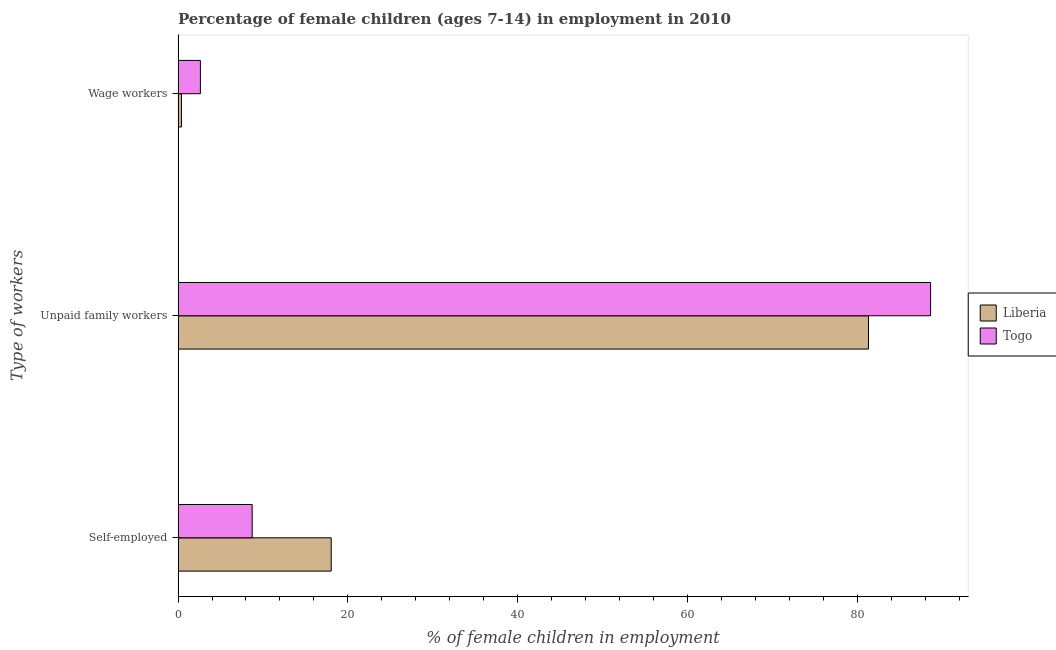How many groups of bars are there?
Ensure brevity in your answer.  3. Are the number of bars on each tick of the Y-axis equal?
Your response must be concise. Yes. How many bars are there on the 1st tick from the top?
Provide a succinct answer. 2. How many bars are there on the 2nd tick from the bottom?
Keep it short and to the point. 2. What is the label of the 1st group of bars from the top?
Give a very brief answer. Wage workers. What is the percentage of children employed as wage workers in Liberia?
Provide a short and direct response. 0.4. Across all countries, what is the maximum percentage of self employed children?
Your answer should be very brief. 18.04. Across all countries, what is the minimum percentage of self employed children?
Offer a terse response. 8.73. In which country was the percentage of children employed as unpaid family workers maximum?
Your response must be concise. Togo. In which country was the percentage of children employed as unpaid family workers minimum?
Your response must be concise. Liberia. What is the total percentage of children employed as wage workers in the graph?
Keep it short and to the point. 3.03. What is the difference between the percentage of self employed children in Togo and that in Liberia?
Your answer should be very brief. -9.31. What is the difference between the percentage of children employed as wage workers in Liberia and the percentage of children employed as unpaid family workers in Togo?
Make the answer very short. -88.24. What is the average percentage of self employed children per country?
Give a very brief answer. 13.38. What is the difference between the percentage of children employed as unpaid family workers and percentage of children employed as wage workers in Togo?
Your response must be concise. 86.01. What is the ratio of the percentage of children employed as wage workers in Liberia to that in Togo?
Ensure brevity in your answer.  0.15. Is the difference between the percentage of self employed children in Togo and Liberia greater than the difference between the percentage of children employed as unpaid family workers in Togo and Liberia?
Provide a short and direct response. No. What is the difference between the highest and the second highest percentage of self employed children?
Your response must be concise. 9.31. What is the difference between the highest and the lowest percentage of children employed as wage workers?
Provide a short and direct response. 2.23. In how many countries, is the percentage of children employed as wage workers greater than the average percentage of children employed as wage workers taken over all countries?
Provide a short and direct response. 1. Is the sum of the percentage of children employed as unpaid family workers in Togo and Liberia greater than the maximum percentage of self employed children across all countries?
Your answer should be compact. Yes. What does the 1st bar from the top in Wage workers represents?
Your response must be concise. Togo. What does the 2nd bar from the bottom in Self-employed represents?
Make the answer very short. Togo. Is it the case that in every country, the sum of the percentage of self employed children and percentage of children employed as unpaid family workers is greater than the percentage of children employed as wage workers?
Ensure brevity in your answer.  Yes. How many bars are there?
Your answer should be very brief. 6. How many countries are there in the graph?
Keep it short and to the point. 2. Are the values on the major ticks of X-axis written in scientific E-notation?
Your answer should be very brief. No. Does the graph contain any zero values?
Provide a succinct answer. No. Where does the legend appear in the graph?
Provide a succinct answer. Center right. How are the legend labels stacked?
Ensure brevity in your answer.  Vertical. What is the title of the graph?
Your answer should be compact. Percentage of female children (ages 7-14) in employment in 2010. What is the label or title of the X-axis?
Offer a very short reply. % of female children in employment. What is the label or title of the Y-axis?
Make the answer very short. Type of workers. What is the % of female children in employment of Liberia in Self-employed?
Provide a succinct answer. 18.04. What is the % of female children in employment of Togo in Self-employed?
Provide a short and direct response. 8.73. What is the % of female children in employment in Liberia in Unpaid family workers?
Ensure brevity in your answer.  81.32. What is the % of female children in employment in Togo in Unpaid family workers?
Ensure brevity in your answer.  88.64. What is the % of female children in employment in Togo in Wage workers?
Ensure brevity in your answer.  2.63. Across all Type of workers, what is the maximum % of female children in employment of Liberia?
Give a very brief answer. 81.32. Across all Type of workers, what is the maximum % of female children in employment in Togo?
Offer a terse response. 88.64. Across all Type of workers, what is the minimum % of female children in employment in Togo?
Offer a terse response. 2.63. What is the total % of female children in employment in Liberia in the graph?
Offer a very short reply. 99.76. What is the difference between the % of female children in employment of Liberia in Self-employed and that in Unpaid family workers?
Keep it short and to the point. -63.28. What is the difference between the % of female children in employment of Togo in Self-employed and that in Unpaid family workers?
Keep it short and to the point. -79.91. What is the difference between the % of female children in employment in Liberia in Self-employed and that in Wage workers?
Keep it short and to the point. 17.64. What is the difference between the % of female children in employment of Liberia in Unpaid family workers and that in Wage workers?
Your response must be concise. 80.92. What is the difference between the % of female children in employment in Togo in Unpaid family workers and that in Wage workers?
Provide a short and direct response. 86.01. What is the difference between the % of female children in employment in Liberia in Self-employed and the % of female children in employment in Togo in Unpaid family workers?
Your answer should be compact. -70.6. What is the difference between the % of female children in employment in Liberia in Self-employed and the % of female children in employment in Togo in Wage workers?
Your response must be concise. 15.41. What is the difference between the % of female children in employment of Liberia in Unpaid family workers and the % of female children in employment of Togo in Wage workers?
Your answer should be very brief. 78.69. What is the average % of female children in employment of Liberia per Type of workers?
Ensure brevity in your answer.  33.25. What is the average % of female children in employment in Togo per Type of workers?
Ensure brevity in your answer.  33.33. What is the difference between the % of female children in employment in Liberia and % of female children in employment in Togo in Self-employed?
Your answer should be compact. 9.31. What is the difference between the % of female children in employment of Liberia and % of female children in employment of Togo in Unpaid family workers?
Keep it short and to the point. -7.32. What is the difference between the % of female children in employment of Liberia and % of female children in employment of Togo in Wage workers?
Give a very brief answer. -2.23. What is the ratio of the % of female children in employment of Liberia in Self-employed to that in Unpaid family workers?
Offer a very short reply. 0.22. What is the ratio of the % of female children in employment of Togo in Self-employed to that in Unpaid family workers?
Your answer should be compact. 0.1. What is the ratio of the % of female children in employment of Liberia in Self-employed to that in Wage workers?
Offer a terse response. 45.1. What is the ratio of the % of female children in employment in Togo in Self-employed to that in Wage workers?
Make the answer very short. 3.32. What is the ratio of the % of female children in employment of Liberia in Unpaid family workers to that in Wage workers?
Your answer should be very brief. 203.3. What is the ratio of the % of female children in employment in Togo in Unpaid family workers to that in Wage workers?
Your answer should be compact. 33.7. What is the difference between the highest and the second highest % of female children in employment in Liberia?
Give a very brief answer. 63.28. What is the difference between the highest and the second highest % of female children in employment in Togo?
Your response must be concise. 79.91. What is the difference between the highest and the lowest % of female children in employment of Liberia?
Keep it short and to the point. 80.92. What is the difference between the highest and the lowest % of female children in employment of Togo?
Provide a succinct answer. 86.01. 